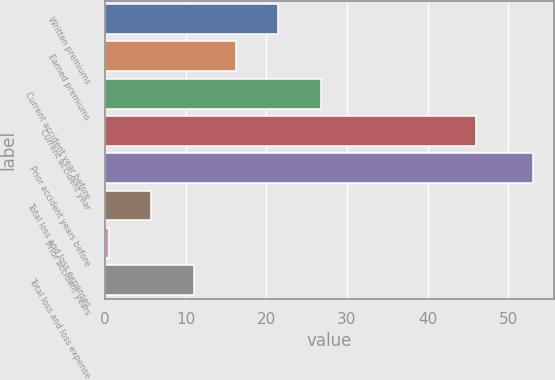Convert chart to OTSL. <chart><loc_0><loc_0><loc_500><loc_500><bar_chart><fcel>Written premiums<fcel>Earned premiums<fcel>Current accident year before<fcel>Current accident year<fcel>Prior accident years before<fcel>Total loss and loss expenses<fcel>Prior accident years<fcel>Total loss and loss expense<nl><fcel>21.5<fcel>16.25<fcel>26.75<fcel>46<fcel>53<fcel>5.75<fcel>0.5<fcel>11<nl></chart> 